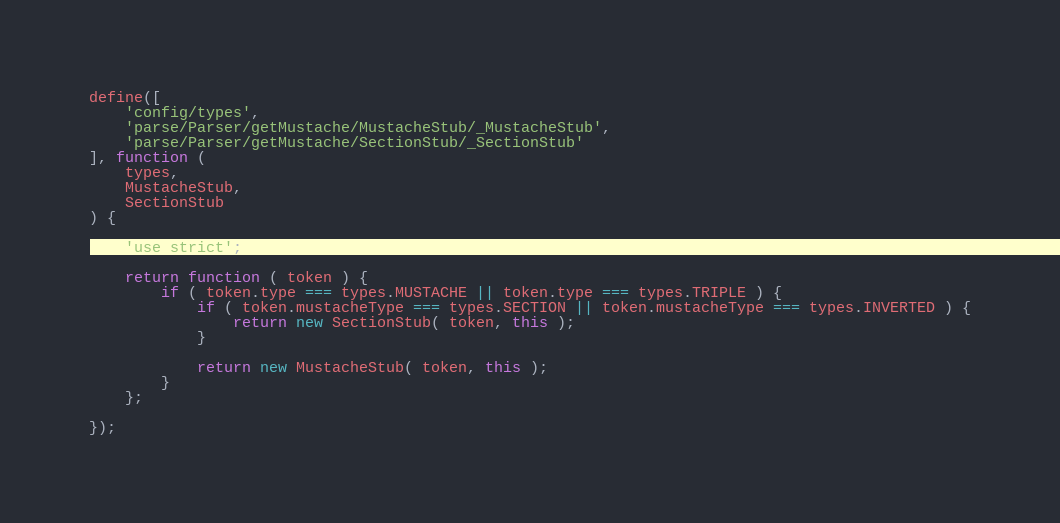Convert code to text. <code><loc_0><loc_0><loc_500><loc_500><_JavaScript_>define([
	'config/types',
	'parse/Parser/getMustache/MustacheStub/_MustacheStub',
	'parse/Parser/getMustache/SectionStub/_SectionStub'
], function (
	types,
	MustacheStub,
	SectionStub
) {

	'use strict';

	return function ( token ) {
		if ( token.type === types.MUSTACHE || token.type === types.TRIPLE ) {
			if ( token.mustacheType === types.SECTION || token.mustacheType === types.INVERTED ) {
				return new SectionStub( token, this );
			}

			return new MustacheStub( token, this );
		}
	};

});</code> 